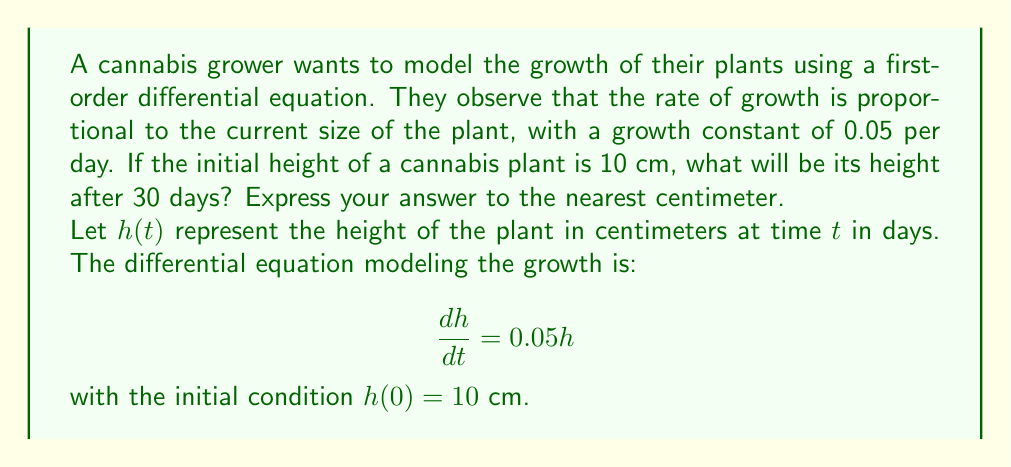Show me your answer to this math problem. To solve this first-order differential equation, we can follow these steps:

1) The general form of the equation is:
   $$\frac{dh}{dt} = kh$$
   where $k = 0.05$ is the growth constant.

2) This is a separable equation. We can rewrite it as:
   $$\frac{dh}{h} = 0.05dt$$

3) Integrating both sides:
   $$\int \frac{dh}{h} = \int 0.05dt$$
   $$\ln|h| = 0.05t + C$$

4) Solving for $h$:
   $$h = e^{0.05t + C} = Ae^{0.05t}$$
   where $A = e^C$ is a constant.

5) Using the initial condition $h(0) = 10$:
   $$10 = Ae^{0.05(0)} = A$$

6) Therefore, the particular solution is:
   $$h(t) = 10e^{0.05t}$$

7) To find the height after 30 days, we evaluate $h(30)$:
   $$h(30) = 10e^{0.05(30)} = 10e^{1.5} \approx 44.82$$

8) Rounding to the nearest centimeter:
   $$h(30) \approx 45 \text{ cm}$$
Answer: 45 cm 